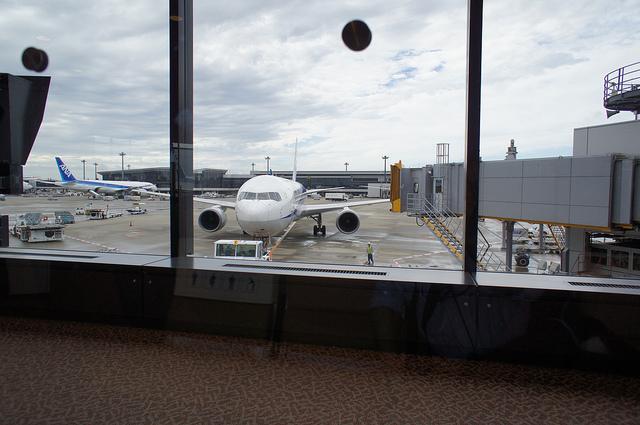Is the plane landing?
Give a very brief answer. No. What color is the second plane?
Answer briefly. Blue. Is the plane ready for take off?
Be succinct. No. What color is the plains trail in the background?
Quick response, please. Blue. What is towing the airplane?
Give a very brief answer. Truck. 